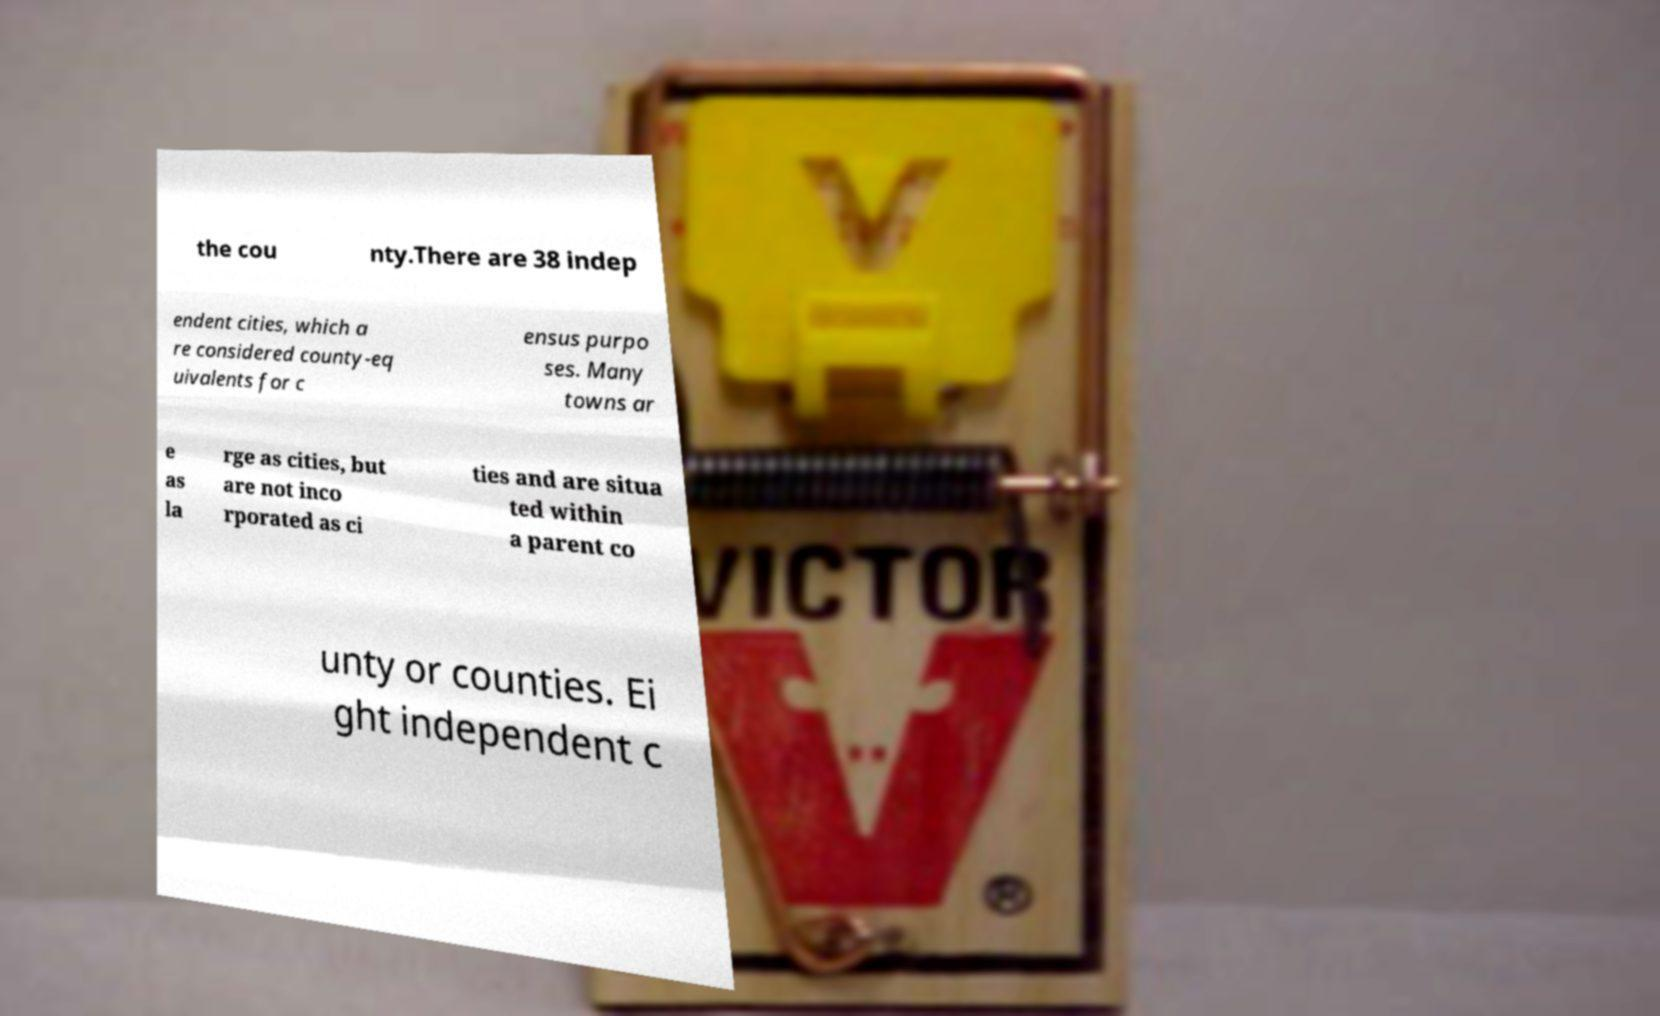What messages or text are displayed in this image? I need them in a readable, typed format. the cou nty.There are 38 indep endent cities, which a re considered county-eq uivalents for c ensus purpo ses. Many towns ar e as la rge as cities, but are not inco rporated as ci ties and are situa ted within a parent co unty or counties. Ei ght independent c 